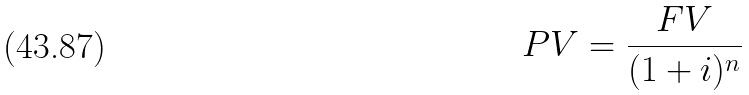<formula> <loc_0><loc_0><loc_500><loc_500>P V = \frac { F V } { ( 1 + i ) ^ { n } }</formula> 